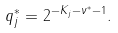<formula> <loc_0><loc_0><loc_500><loc_500>q _ { j } ^ { * } = 2 ^ { { - K } _ { j } - \nu ^ { * } - 1 } .</formula> 